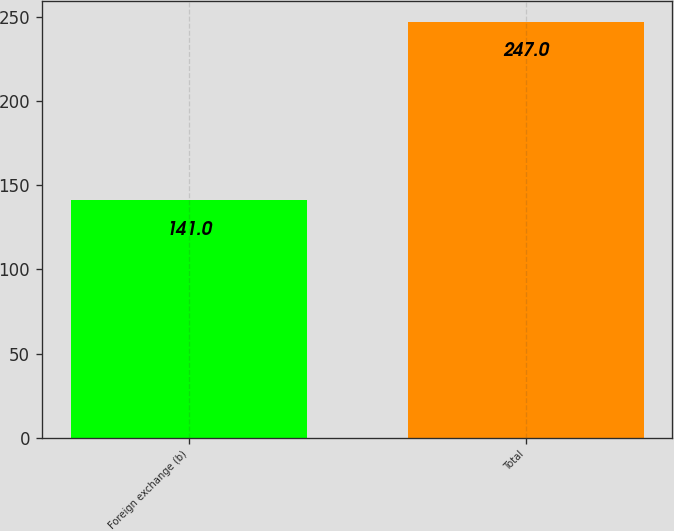<chart> <loc_0><loc_0><loc_500><loc_500><bar_chart><fcel>Foreign exchange (b)<fcel>Total<nl><fcel>141<fcel>247<nl></chart> 